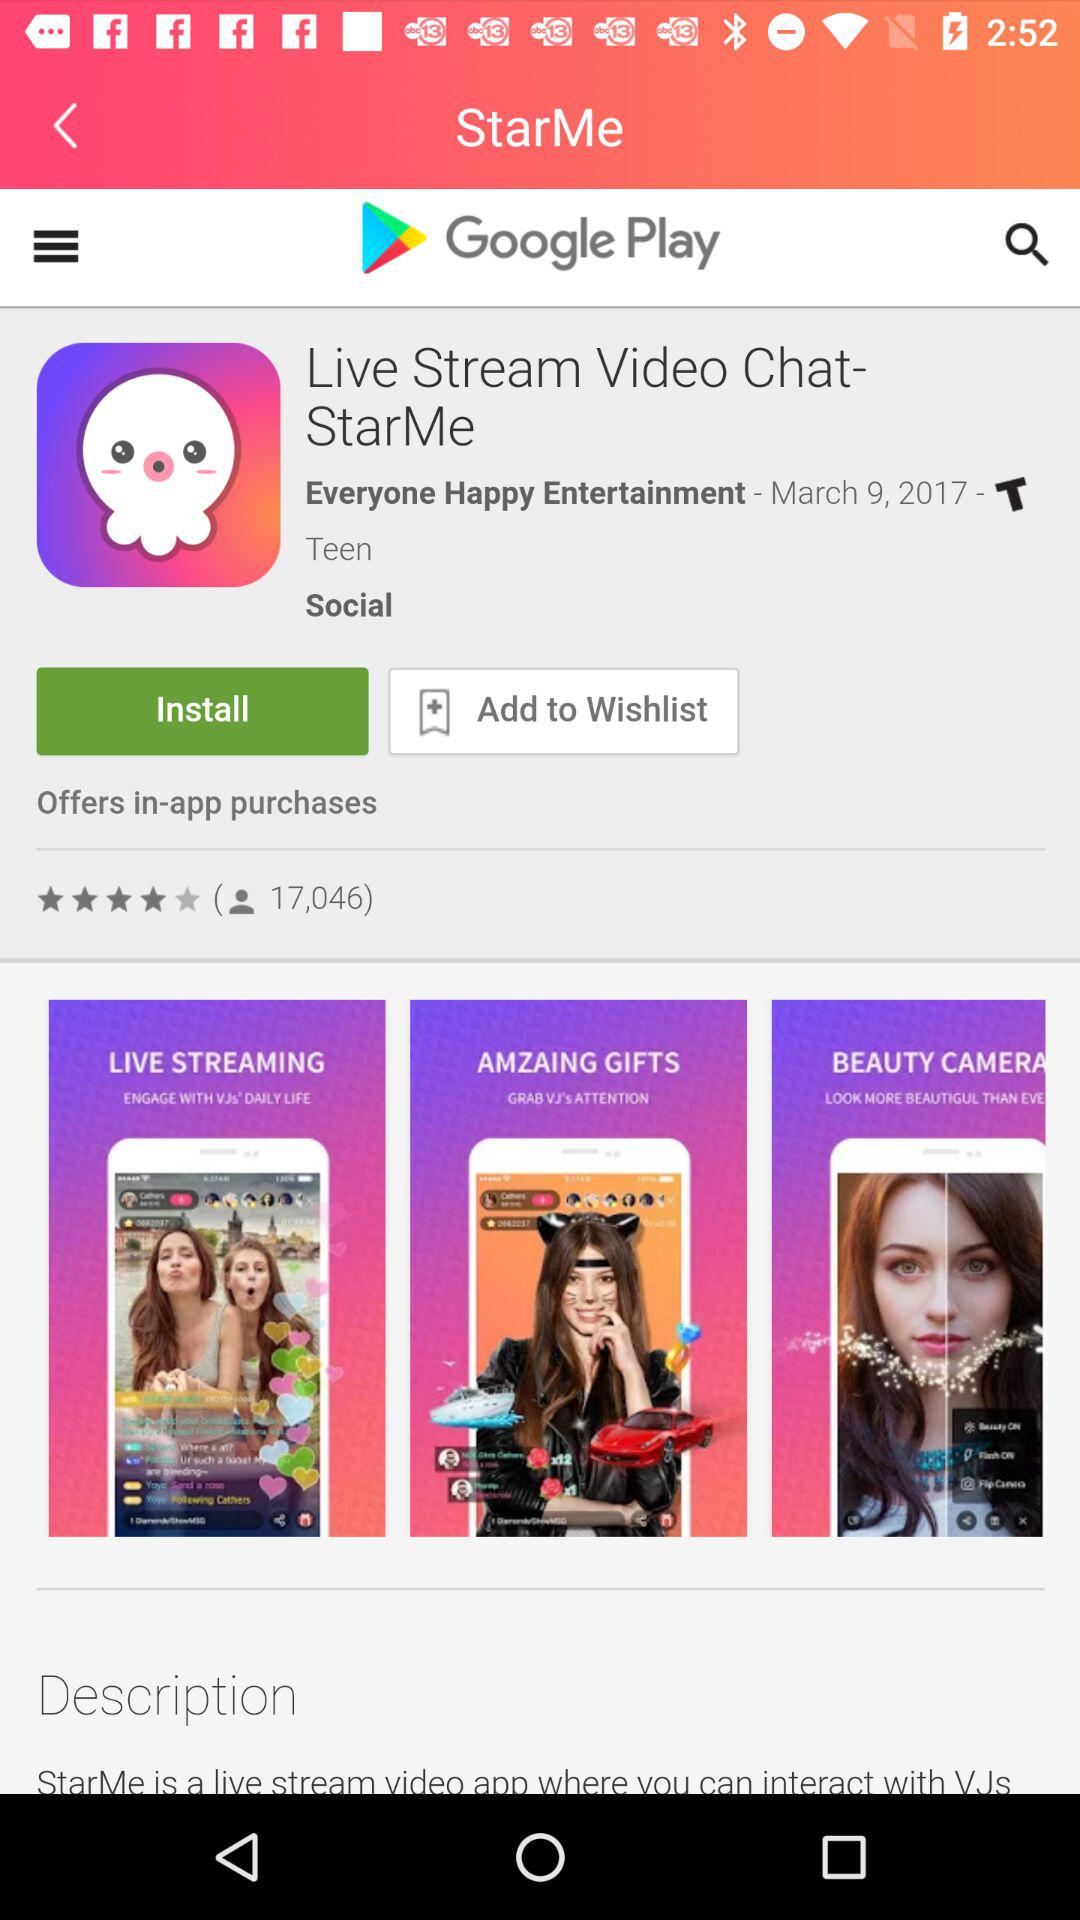What is the name of the application? The name of the application is "Live Stream Video Chat-StarMe". 